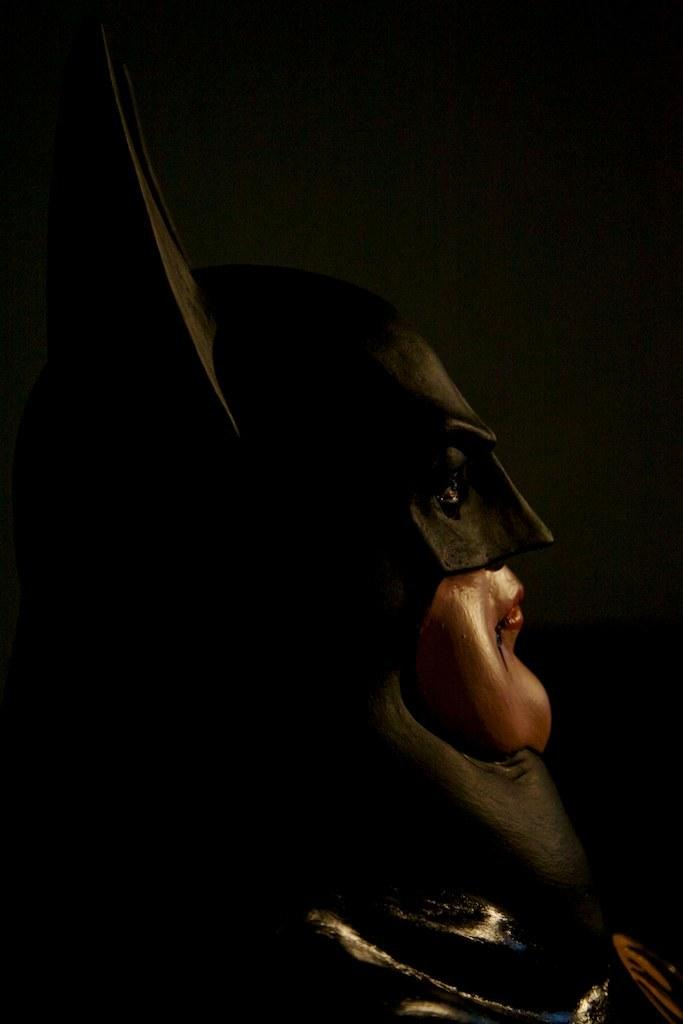What is the main subject of the image? The main subject of the image is a person. Can you describe what the person is wearing? The person is wearing a mask. What is the color of the background in the image? The background of the image is dark. What type of jelly can be seen on the roof in the image? There is no jelly or roof present in the image. What type of leaf is visible in the image? There is no leaf present in the image. 